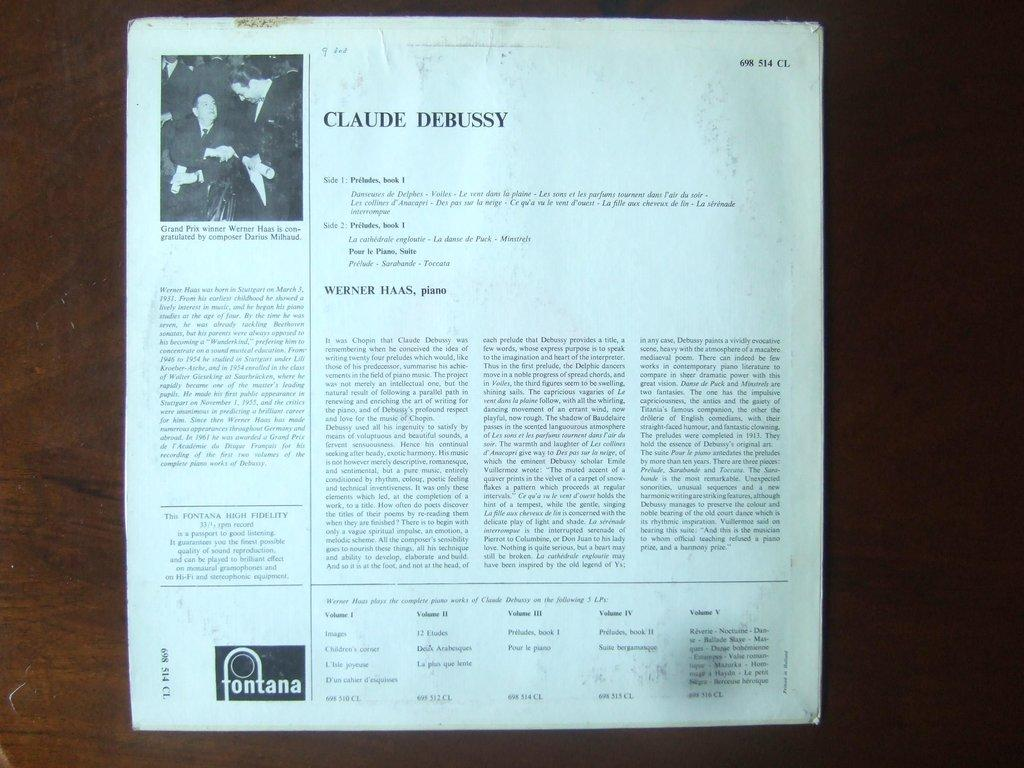<image>
Relay a brief, clear account of the picture shown. A article about Claude Debussy with a picture on the top left 